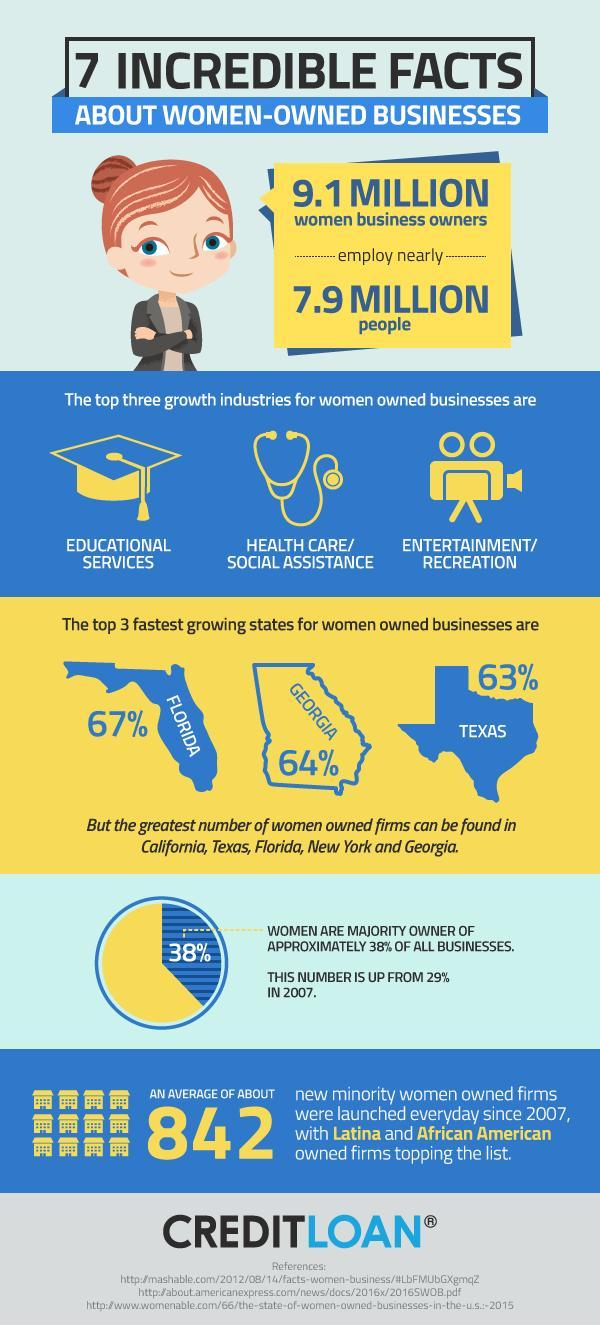What percentage of businesses are owned by men?
Answer the question with a short phrase. 62% What is the percentage increase of firms owned by women since 2007 to 2015? 9% What is the highest percentage of women owned business in the US, 63%, 64%, or 67%? 67% Which are the top 3 states in the US that promotes women entrepreneurs? Florida, Georgia, Texas 